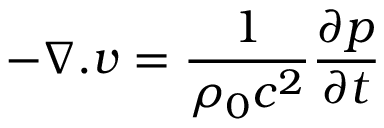<formula> <loc_0><loc_0><loc_500><loc_500>- \nabla . v = \frac { 1 } { \rho _ { 0 } c ^ { 2 } } \frac { \partial p } { \partial t }</formula> 